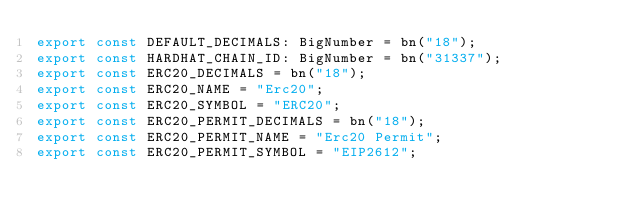Convert code to text. <code><loc_0><loc_0><loc_500><loc_500><_TypeScript_>export const DEFAULT_DECIMALS: BigNumber = bn("18");
export const HARDHAT_CHAIN_ID: BigNumber = bn("31337");
export const ERC20_DECIMALS = bn("18");
export const ERC20_NAME = "Erc20";
export const ERC20_SYMBOL = "ERC20";
export const ERC20_PERMIT_DECIMALS = bn("18");
export const ERC20_PERMIT_NAME = "Erc20 Permit";
export const ERC20_PERMIT_SYMBOL = "EIP2612";
</code> 